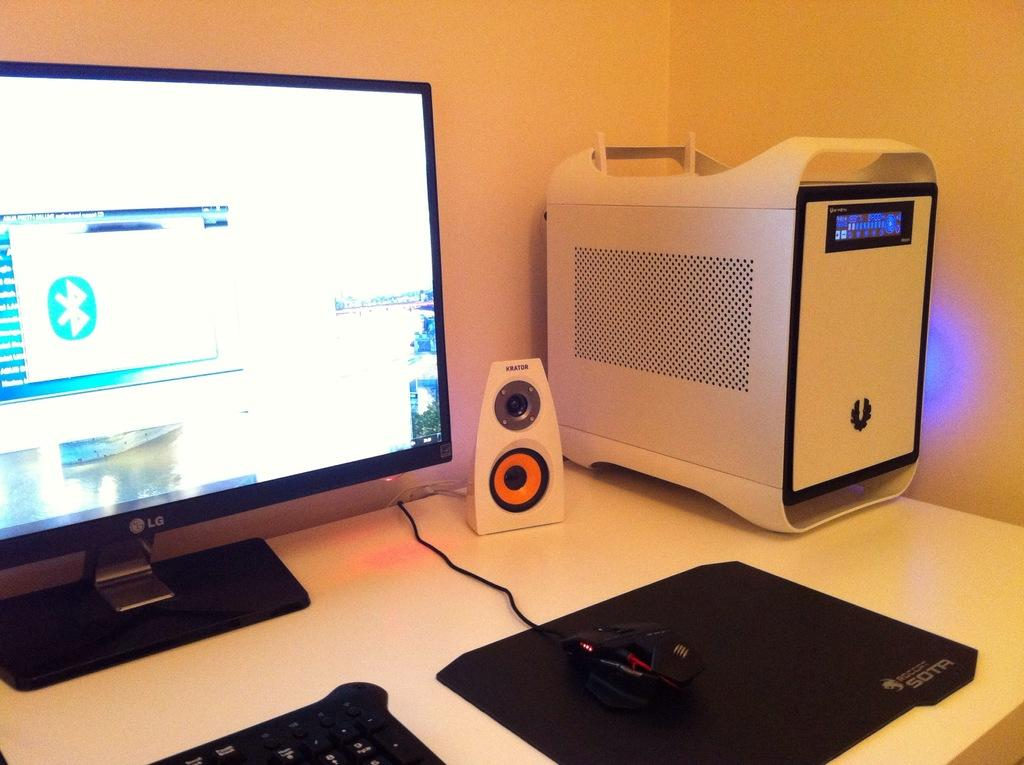<image>
Share a concise interpretation of the image provided. A computer set-up with a Krator brand speaker. 